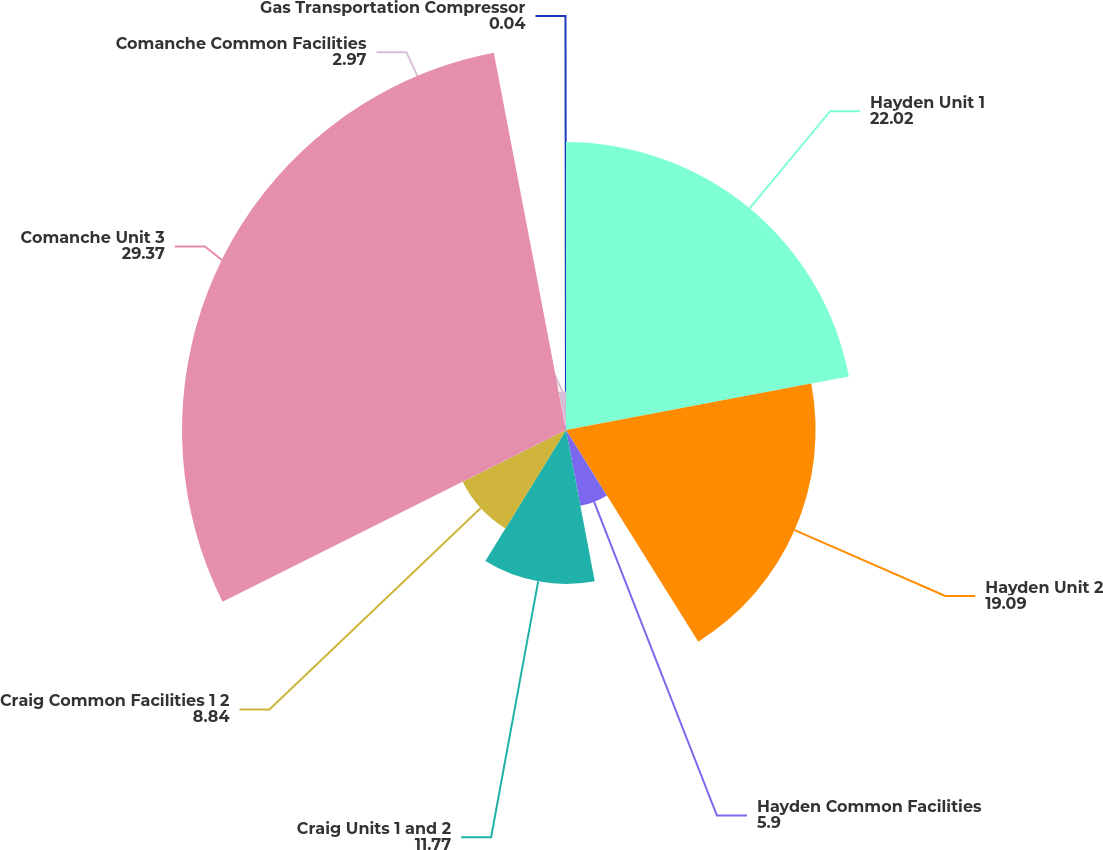Convert chart to OTSL. <chart><loc_0><loc_0><loc_500><loc_500><pie_chart><fcel>Hayden Unit 1<fcel>Hayden Unit 2<fcel>Hayden Common Facilities<fcel>Craig Units 1 and 2<fcel>Craig Common Facilities 1 2<fcel>Comanche Unit 3<fcel>Comanche Common Facilities<fcel>Gas Transportation Compressor<nl><fcel>22.02%<fcel>19.09%<fcel>5.9%<fcel>11.77%<fcel>8.84%<fcel>29.37%<fcel>2.97%<fcel>0.04%<nl></chart> 